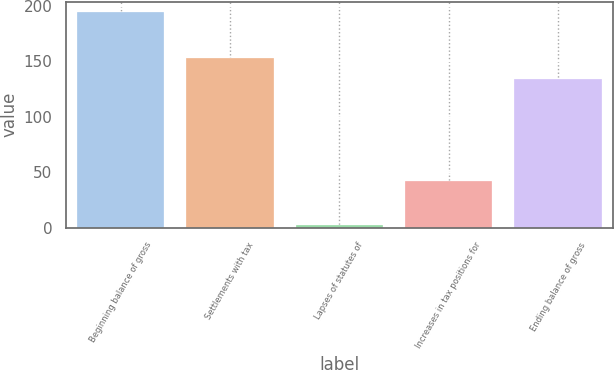Convert chart to OTSL. <chart><loc_0><loc_0><loc_500><loc_500><bar_chart><fcel>Beginning balance of gross<fcel>Settlements with tax<fcel>Lapses of statutes of<fcel>Increases in tax positions for<fcel>Ending balance of gross<nl><fcel>194<fcel>153.2<fcel>2<fcel>42<fcel>134<nl></chart> 